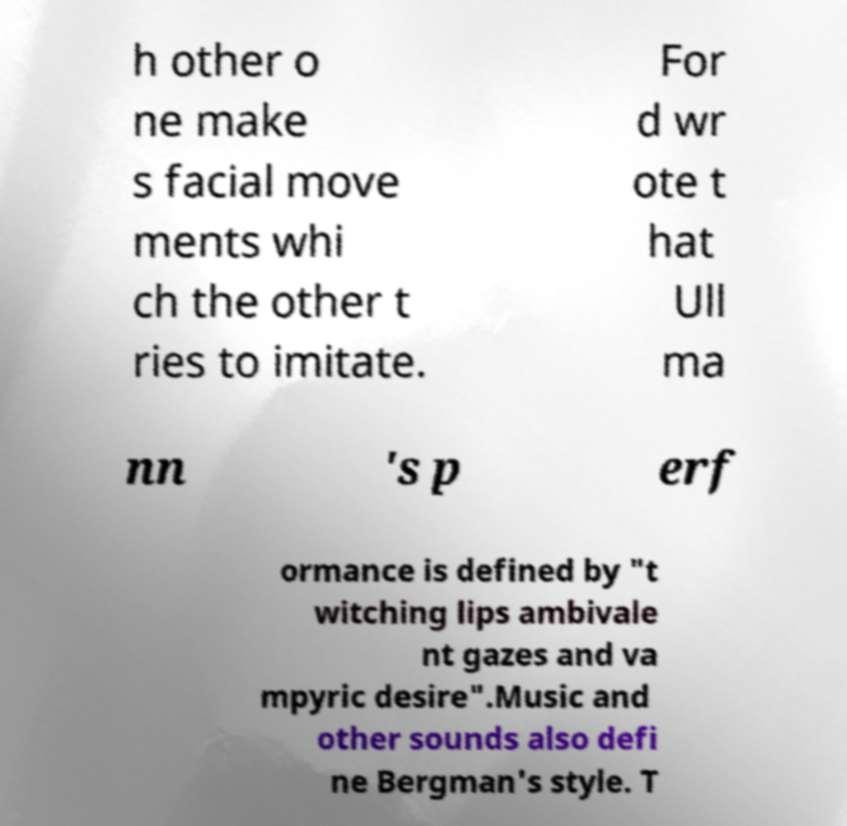Please read and relay the text visible in this image. What does it say? h other o ne make s facial move ments whi ch the other t ries to imitate. For d wr ote t hat Ull ma nn 's p erf ormance is defined by "t witching lips ambivale nt gazes and va mpyric desire".Music and other sounds also defi ne Bergman's style. T 